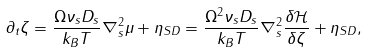<formula> <loc_0><loc_0><loc_500><loc_500>\partial _ { t } \zeta = \frac { \Omega \nu _ { s } D _ { s } } { k _ { B } T } \nabla _ { s } ^ { 2 } \mu + \eta _ { S D } = \frac { \Omega ^ { 2 } \nu _ { s } D _ { s } } { k _ { B } T } \nabla _ { s } ^ { 2 } \frac { \delta { \mathcal { H } } } { \delta \zeta } + \eta _ { S D } ,</formula> 